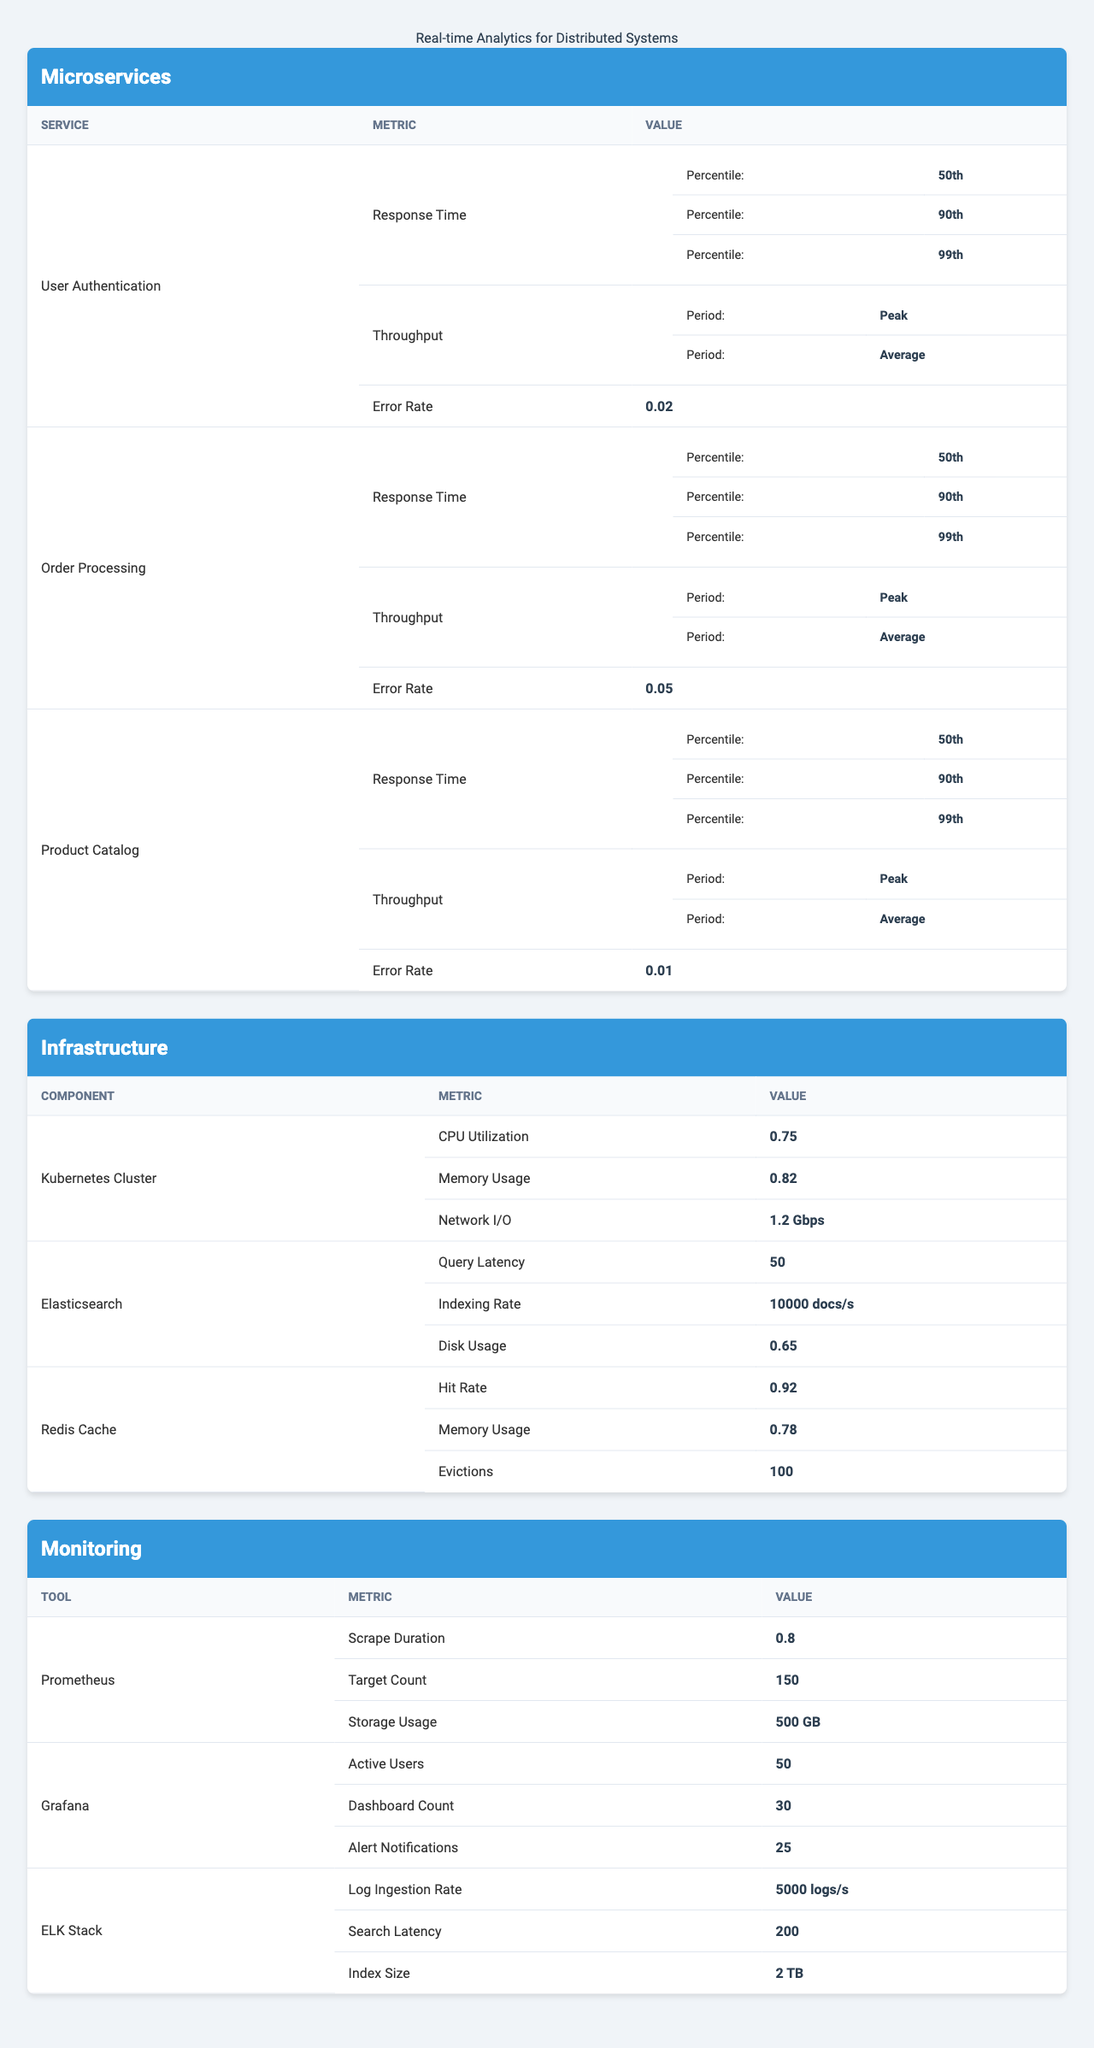What is the 90th percentile response time of the User Authentication microservice? The User Authentication microservice has a 90th percentile response time listed as 120 milliseconds in the table.
Answer: 120 milliseconds What is the error rate for the Product Catalog service? Based on the table, the error rate for the Product Catalog service is 0.01 (or 1%).
Answer: 0.01 Which microservice has the highest peak throughput? The Product Catalog service has the highest peak throughput with 8000 requests, compared to User Authentication's 5000 and Order Processing's 2000 requests.
Answer: Product Catalog Calculate the average error rate across all microservices. The error rates for the microservices are 0.02 (User Authentication), 0.05 (Order Processing), and 0.01 (Product Catalog). The average error rate is (0.02 + 0.05 + 0.01) / 3 = 0.0267 or approximately 0.03.
Answer: 0.03 Does the Kubernetes Cluster have a CPU utilization statistic above 0.7? Yes, the table shows the CPU Utilization for the Kubernetes cluster as 0.75, which is above 0.7.
Answer: Yes Which tool has the highest storage usage according to the monitoring metrics? The ELK Stack tool has the highest storage usage at 2 TB, compared to Prometheus with 500 GB and Grafana not specified.
Answer: ELK Stack Is the average throughput of the Order Processing service higher than the 50th percentile response time? The average throughput for the Order Processing service is recorded at 800 requests, while the 50th percentile response time is 150 milliseconds. Since these metrics are not directly comparable (throughput is in requests whereas response time is in milliseconds), the question is somewhat flawed.
Answer: Not applicable What is the difference between the peak throughput of User Authentication and Order Processing? User Authentication has a peak throughput of 5000 requests and Order Processing has 2000 requests. The difference is 5000 - 2000 = 3000 requests.
Answer: 3000 requests What is the latency for the Elasticsearch query? According to the table, the query latency for Elasticsearch is 50 milliseconds.
Answer: 50 milliseconds Which component has the highest memory usage? The component with the highest memory usage is the Elasticsearch with a usage value of 0.65, compared to Kubernetes Cluster at 0.82 and Redis Cache at 0.78 (the latter two values, however, are higher than the former).
Answer: Kubernetes Cluster What is the total memory usage across the Kubernetes Cluster and Redis Cache? The Kubernetes Cluster memory usage is 0.82 and Redis Cache is 0.78, totaling 0.82 + 0.78 = 1.6 (or 160%).
Answer: 1.6 Which microservice has the lowest 99th percentile response time? The Product Catalog microservice has the lowest 99th percentile response time at 150 milliseconds, compared to User Authentication at 250 milliseconds and Order Processing at 500 milliseconds.
Answer: Product Catalog 